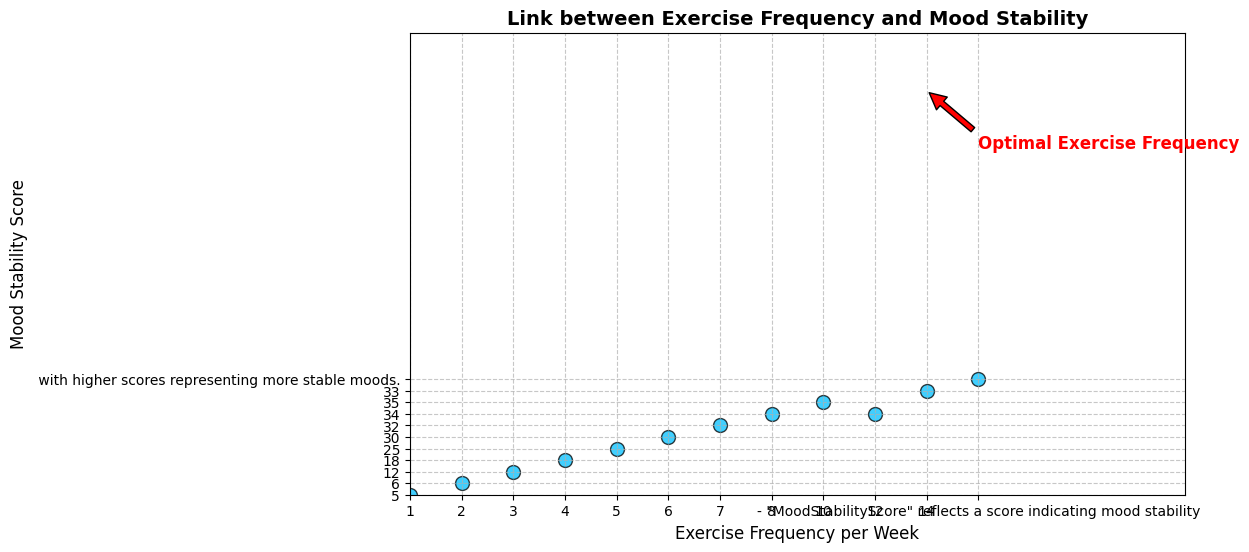What is the highest Mood Stability Score recorded in the plot? The highest Mood Stability Score can be identified by looking for the data point with the highest value on the y-axis. The maximum value on the y-axis is 35.
Answer: 35 What is the optimal exercise frequency per week for mood stability, as indicated by the annotation? The annotation on the plot points to a specific exercise frequency that is considered optimal. According to the annotation, this optimal point is 10 exercises per week.
Answer: 10 By how much does the Mood Stability Score increase when the Exercise Frequency per Week goes from 1 to 4? Find the Mood Stability Scores for Exercise Frequencies of 1 and 4, which are 5 and 18 respectively. Then calculate the difference: 18 - 5.
Answer: 13 Is there an increasing trend in Mood Stability Score with an increase in Exercise Frequency per Week? Observing the plot, we notice that as the Exercise Frequency increases from 1 to about 10 per week, the Mood Stability Score consistently increases, showing an overall upward trend.
Answer: Yes What exercise frequency per week results in the maximum Mood Stability Score? The point at the peak Mood Stability Score (35) is at an Exercise Frequency of 10 per week, indicating that this frequency results in the maximum score.
Answer: 10 At what Exercise Frequency per Week do mood stability scores begin to plateau or slightly decrease? After an Exercise Frequency of 10 per week where the score is 35, the scores plateau around 34 and slightly decrease, as seen by the scores of 34 at 12 exercises per week and 33 at 14 exercises per week.
Answer: 12-14 What is the average Mood Stability Score for Exercise Frequencies of 5, 6, and 7 per week? First, identify the Mood Stability Scores at these frequencies: 25, 30, and 32. Calculate the average: (25 + 30 + 32) / 3 = 87 / 3.
Answer: 29 Does any Exercise Frequency per Week yield the same Mood Stability Score? According to the data points, only the Exercise Frequencies of 8 and 12 per week yield the same Mood Stability Score of 34.
Answer: Yes At which Exercise Frequency per Week does the Mood Stability Score make its largest jump? Calculate the differences between subsequent Mood Stability Scores. The largest jump occurs between the Exercise Frequencies of 2 and 3 per week, with an increase from 6 to 12, a difference of 6.
Answer: Between 2 and 3 